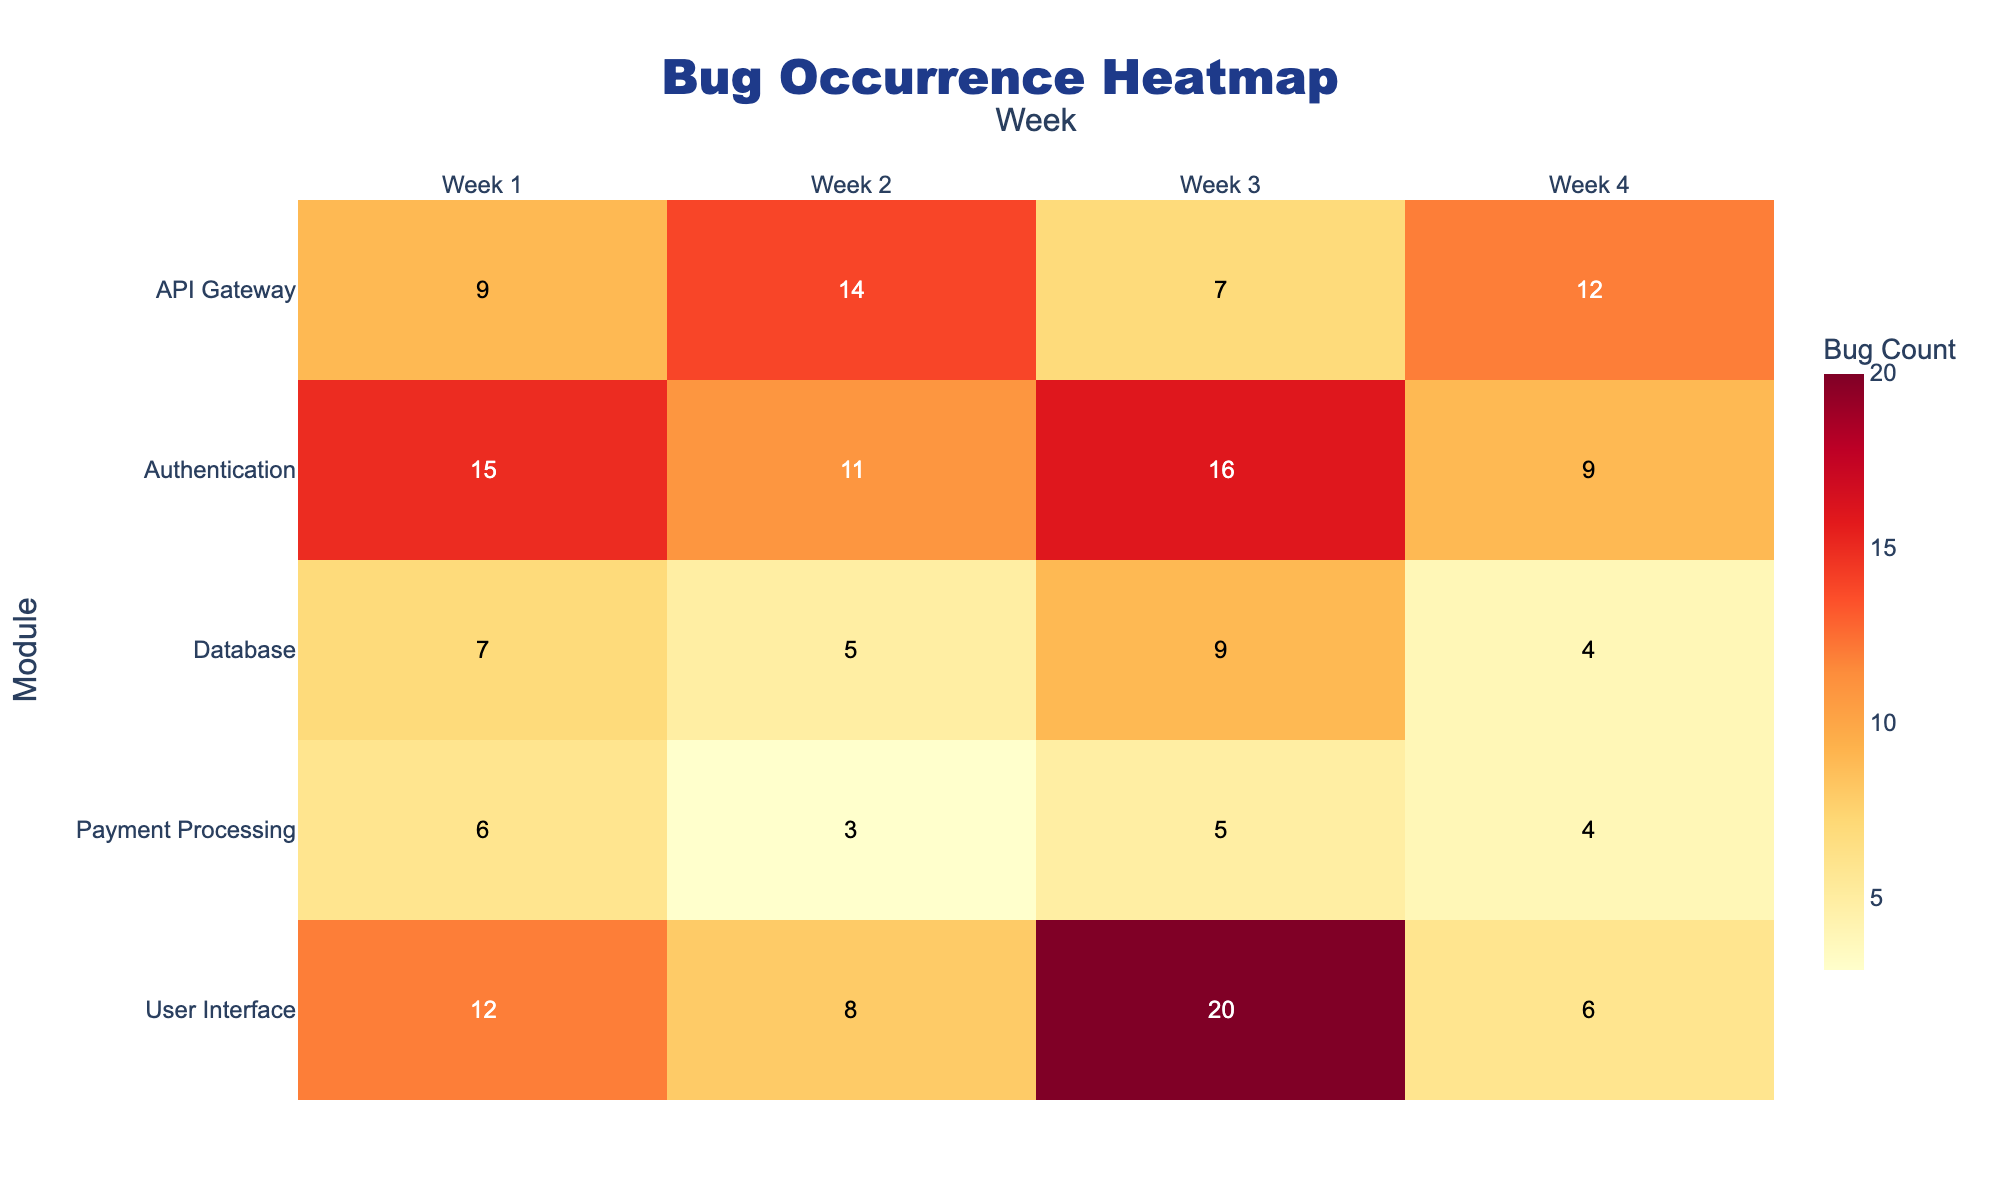What is the title of the heatmap? The title of the heatmap is prominently placed at the top, generally in a larger and bold font compared to the rest of the text. Here, the title reads "Bug Occurrence Heatmap".
Answer: Bug Occurrence Heatmap Which module had the highest number of bugs in Week 3? To find this, look at the column for Week 3. Scan down the column to find the highest numerical value. For Week 3, the highest number of bugs is 20 in the User Interface module.
Answer: User Interface Which week did the Database module have the highest bug count, and what was the count? Focus on the row for the Database module. Identify the highest number in this row, which is 9 in Week 3.
Answer: Week 3, 9 bugs What’s the total number of bugs reported in the API Gateway module over 4 weeks? Add the bug counts for the API Gateway module for all weeks: 9 (Week 1) + 14 (Week 2) + 7 (Week 3) + 12 (Week 4). This sums up to 42.
Answer: 42 Which module experienced the biggest decrease in bug count between two consecutive weeks, and what was the decrease? To find this, compare the bug counts within each module between consecutive weeks and identify differences. The User Interface module had a drop from 20 bugs in Week 3 to 6 bugs in Week 4, a decrease of 14.
Answer: User Interface, 14 How does the bug count in Week 4 for the User Interface module compare to the Authentication module? For this, look at the Week 4 column and compare the counts for User Interface (6) and Authentication (9). The User Interface module has 3 fewer bugs than the Authentication module.
Answer: 3 fewer What is the average number of bugs in the Payment Processing module over the 4 weeks? Calculate the average by summing the bug counts and dividing by the number of weeks: (6 + 3 + 5 + 4) / 4 = 18 / 4 = 4.5.
Answer: 4.5 How many weeks did any module report exactly 7 bugs? Scan the entire heatmap to count the instances of the value 7. It occurs three times: Database in Week 3, API Gateway in Week 3, and User Interface in Week 2.
Answer: 3 Which module had the least bugs on average over the 4 weeks? Calculate the average number of bugs in each module, then find the smallest average. For Payment Processing: (6+3+5+4)/4 = 4.5, which is the smallest average among all modules.
Answer: Payment Processing Identify the modules that didn't have any week with bug counts exceeding 10. Review each module to check if any of their weekly bug counts exceeded 10. The modules where no week's bug count exceeds 10 are Database and Payment Processing.
Answer: Database, Payment Processing 